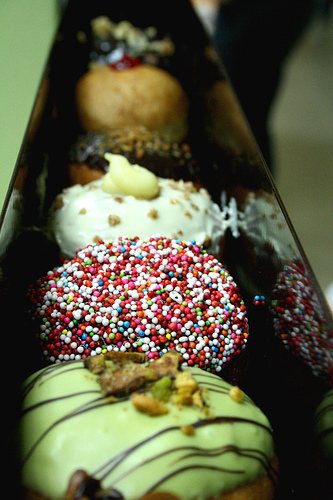Which doughnut looks the most unique and why? The doughnut that looks the most unique is the one with the green drizzle on white frosting. Its color scheme stands out from the others and the green drizzle suggests a unique flavor such as pistachio, matcha, or mint, which are less common compared to the other more traditional toppings. 